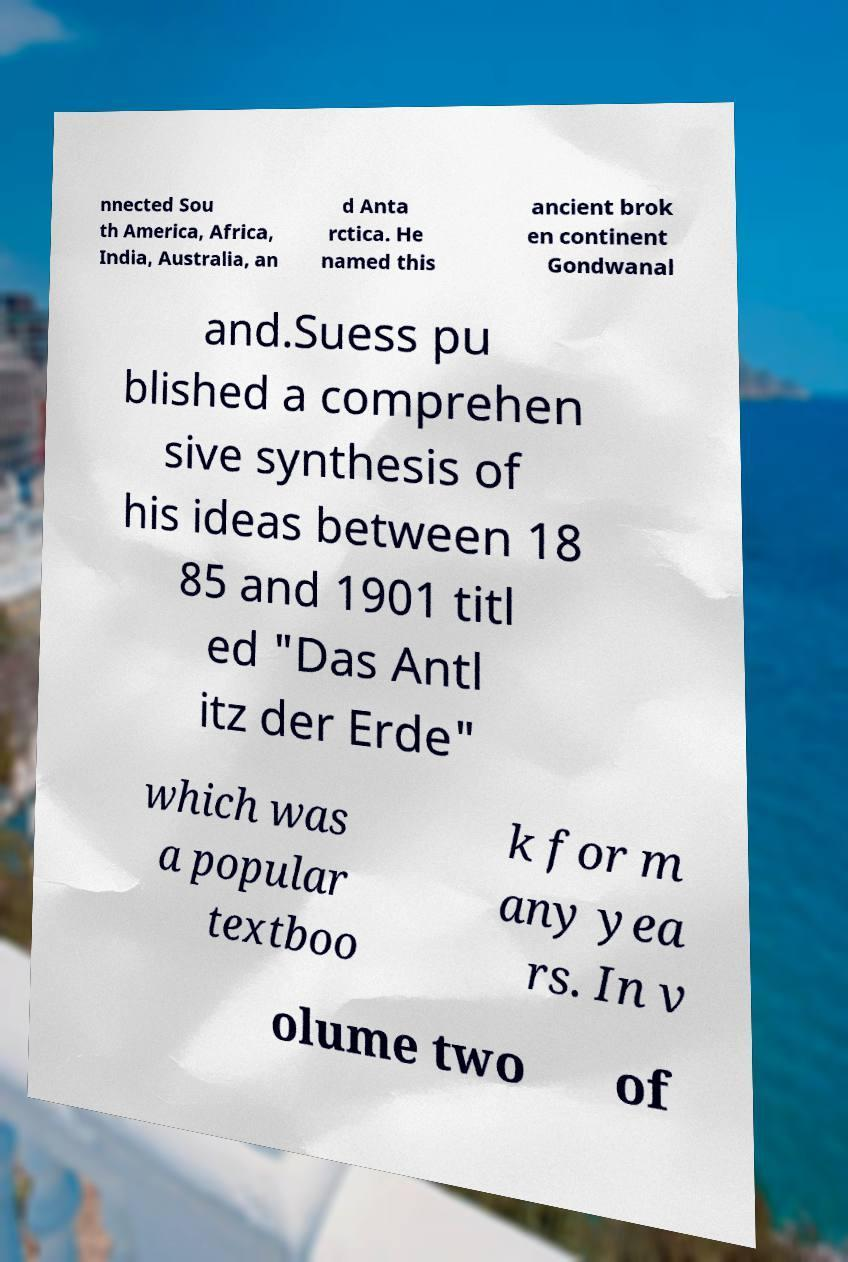Please read and relay the text visible in this image. What does it say? nnected Sou th America, Africa, India, Australia, an d Anta rctica. He named this ancient brok en continent Gondwanal and.Suess pu blished a comprehen sive synthesis of his ideas between 18 85 and 1901 titl ed "Das Antl itz der Erde" which was a popular textboo k for m any yea rs. In v olume two of 